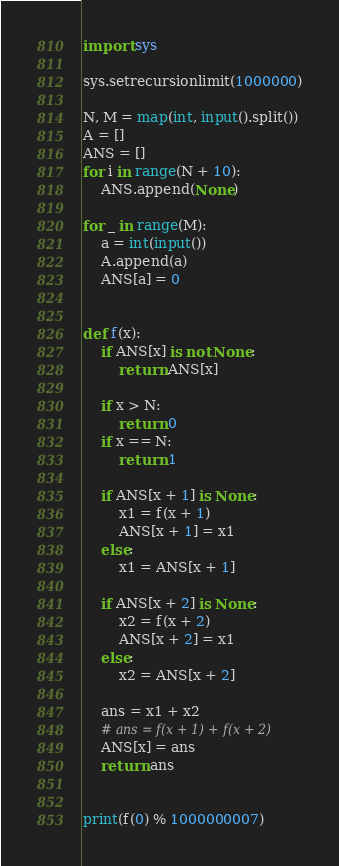Convert code to text. <code><loc_0><loc_0><loc_500><loc_500><_Python_>import sys

sys.setrecursionlimit(1000000)

N, M = map(int, input().split())
A = []
ANS = []
for i in range(N + 10):
    ANS.append(None)

for _ in range(M):
    a = int(input())
    A.append(a)
    ANS[a] = 0


def f(x):
    if ANS[x] is not None:
        return ANS[x]

    if x > N:
        return 0
    if x == N:
        return 1

    if ANS[x + 1] is None:
        x1 = f(x + 1)
        ANS[x + 1] = x1
    else:
        x1 = ANS[x + 1]

    if ANS[x + 2] is None:
        x2 = f(x + 2)
        ANS[x + 2] = x1
    else:
        x2 = ANS[x + 2]

    ans = x1 + x2
    # ans = f(x + 1) + f(x + 2)
    ANS[x] = ans
    return ans


print(f(0) % 1000000007)
</code> 